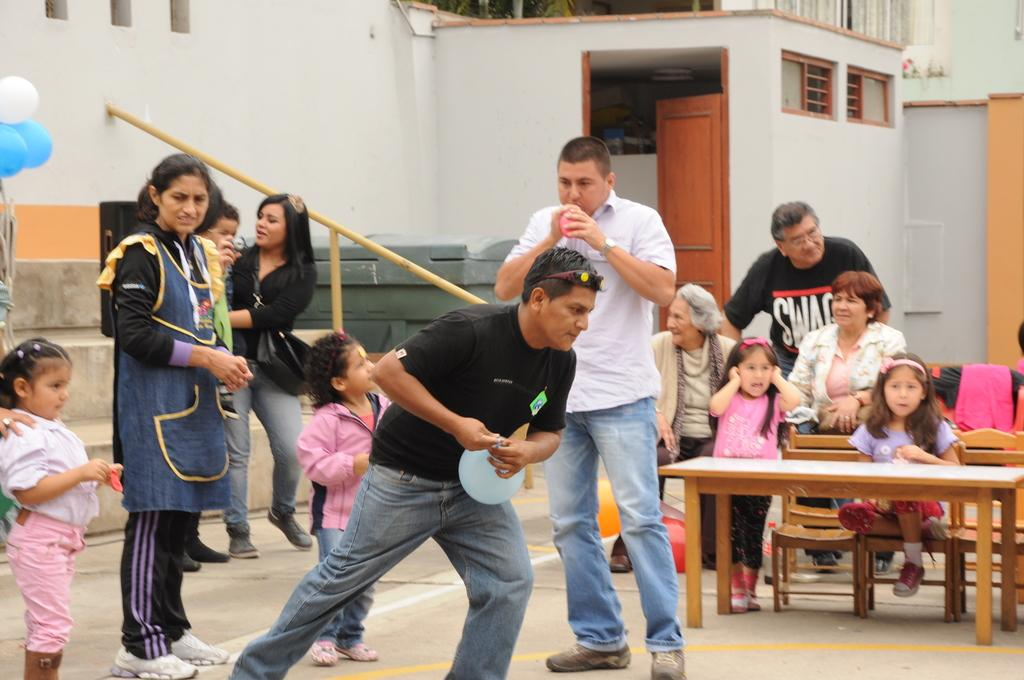How many people are in the image? There are people in the image, but the exact number is not specified. What type of furniture is present in the image? There are chairs and a table in the image. What architectural features can be seen in the image? There is a wall and a door in the image. What object is being held by one of the people in the image? A person is holding a balloon in the image. What type of plantation is visible in the image? There is no plantation present in the image. What minister is attending the event in the image? There is no minister or event depicted in the image. 